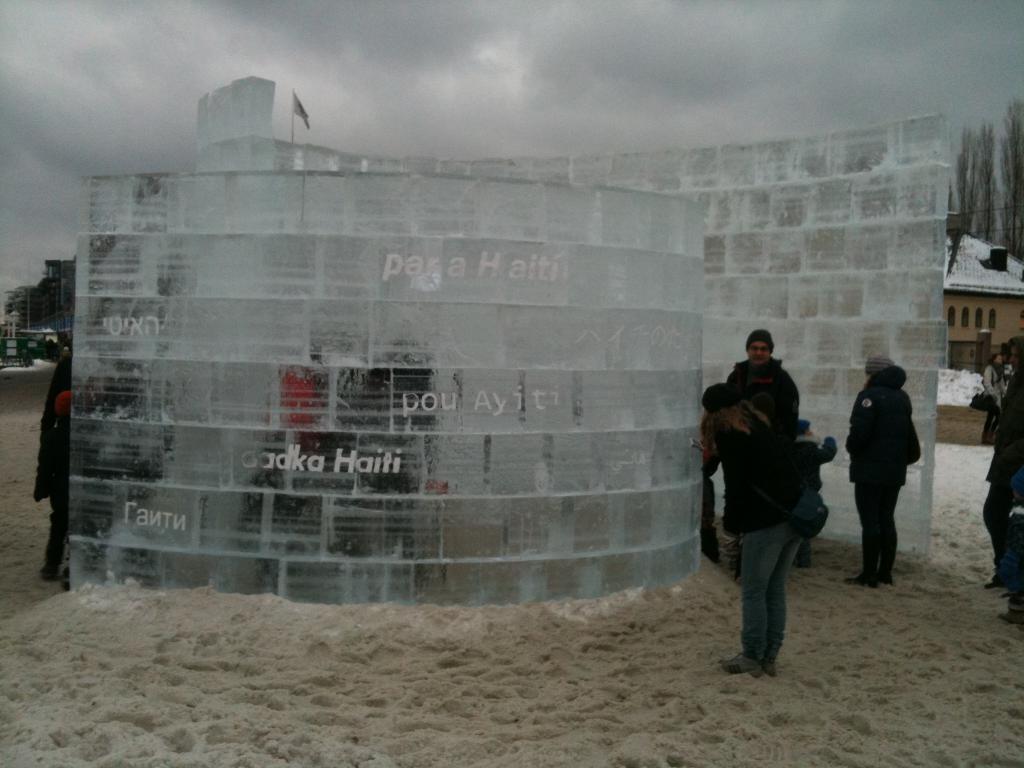Please provide a concise description of this image. In this image I can see two brick walls on the sand ground. I can also see something is written on the wall. I can see few people are standing near the walls and I can see all of them are wearing jackets. In the background I can see few buildings, few trees, clouds, a flag and the sky. 